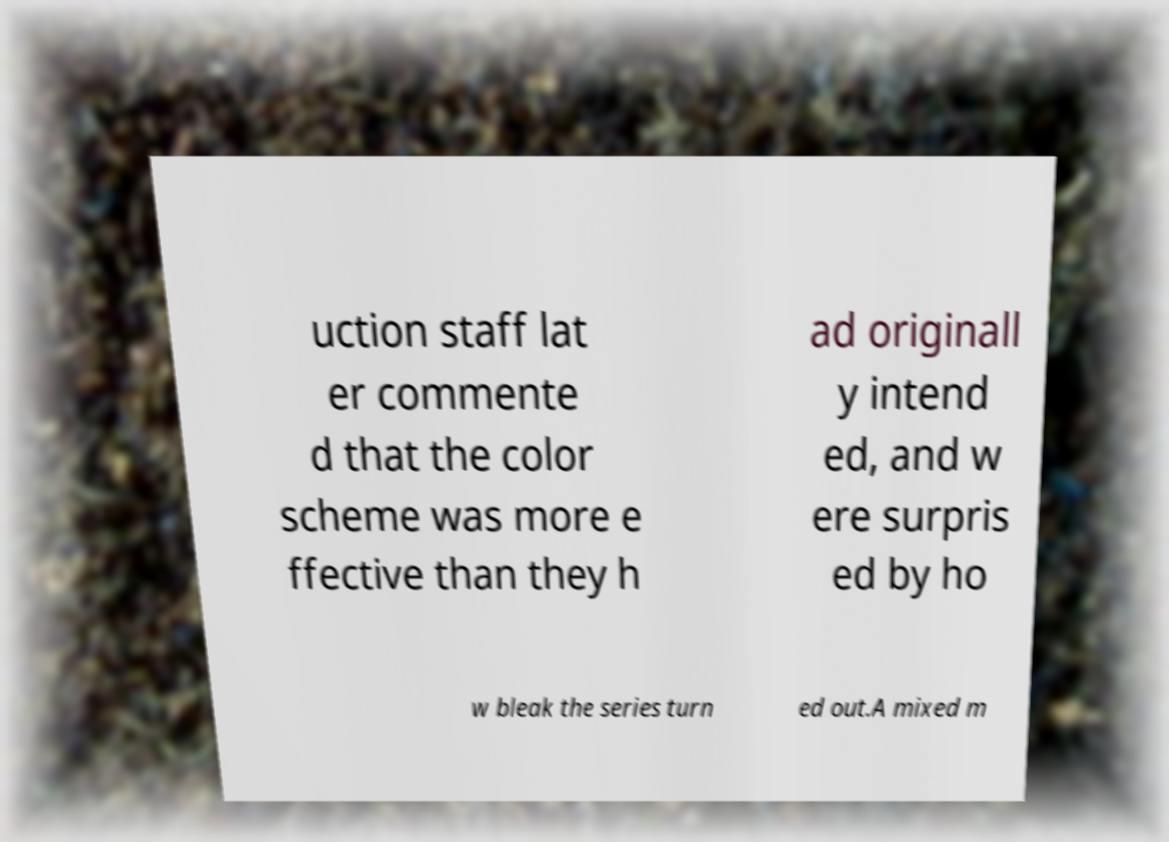Could you assist in decoding the text presented in this image and type it out clearly? uction staff lat er commente d that the color scheme was more e ffective than they h ad originall y intend ed, and w ere surpris ed by ho w bleak the series turn ed out.A mixed m 